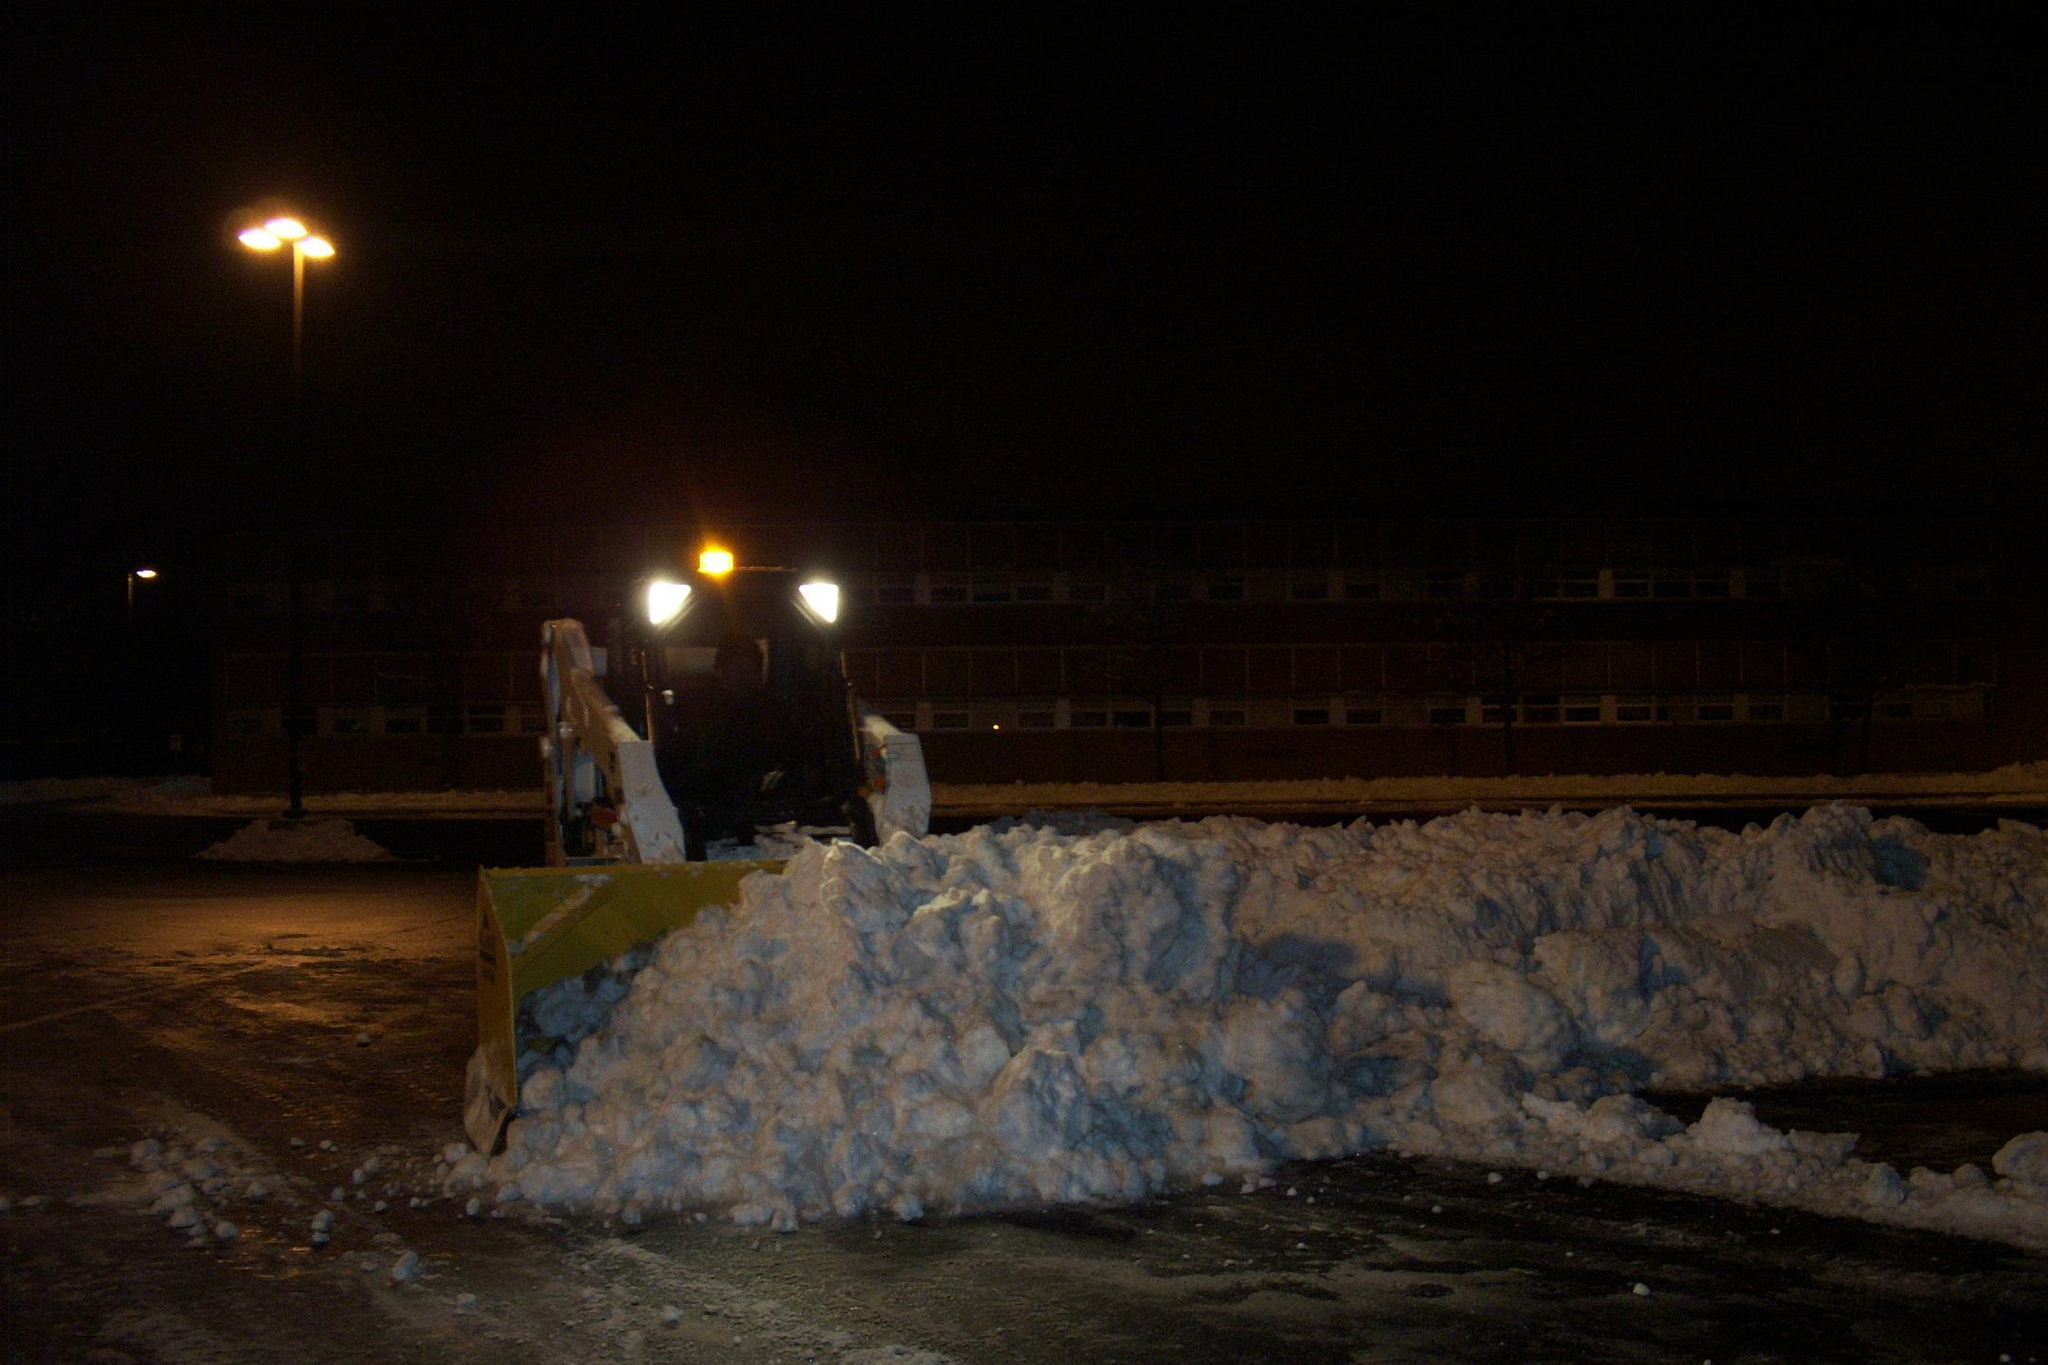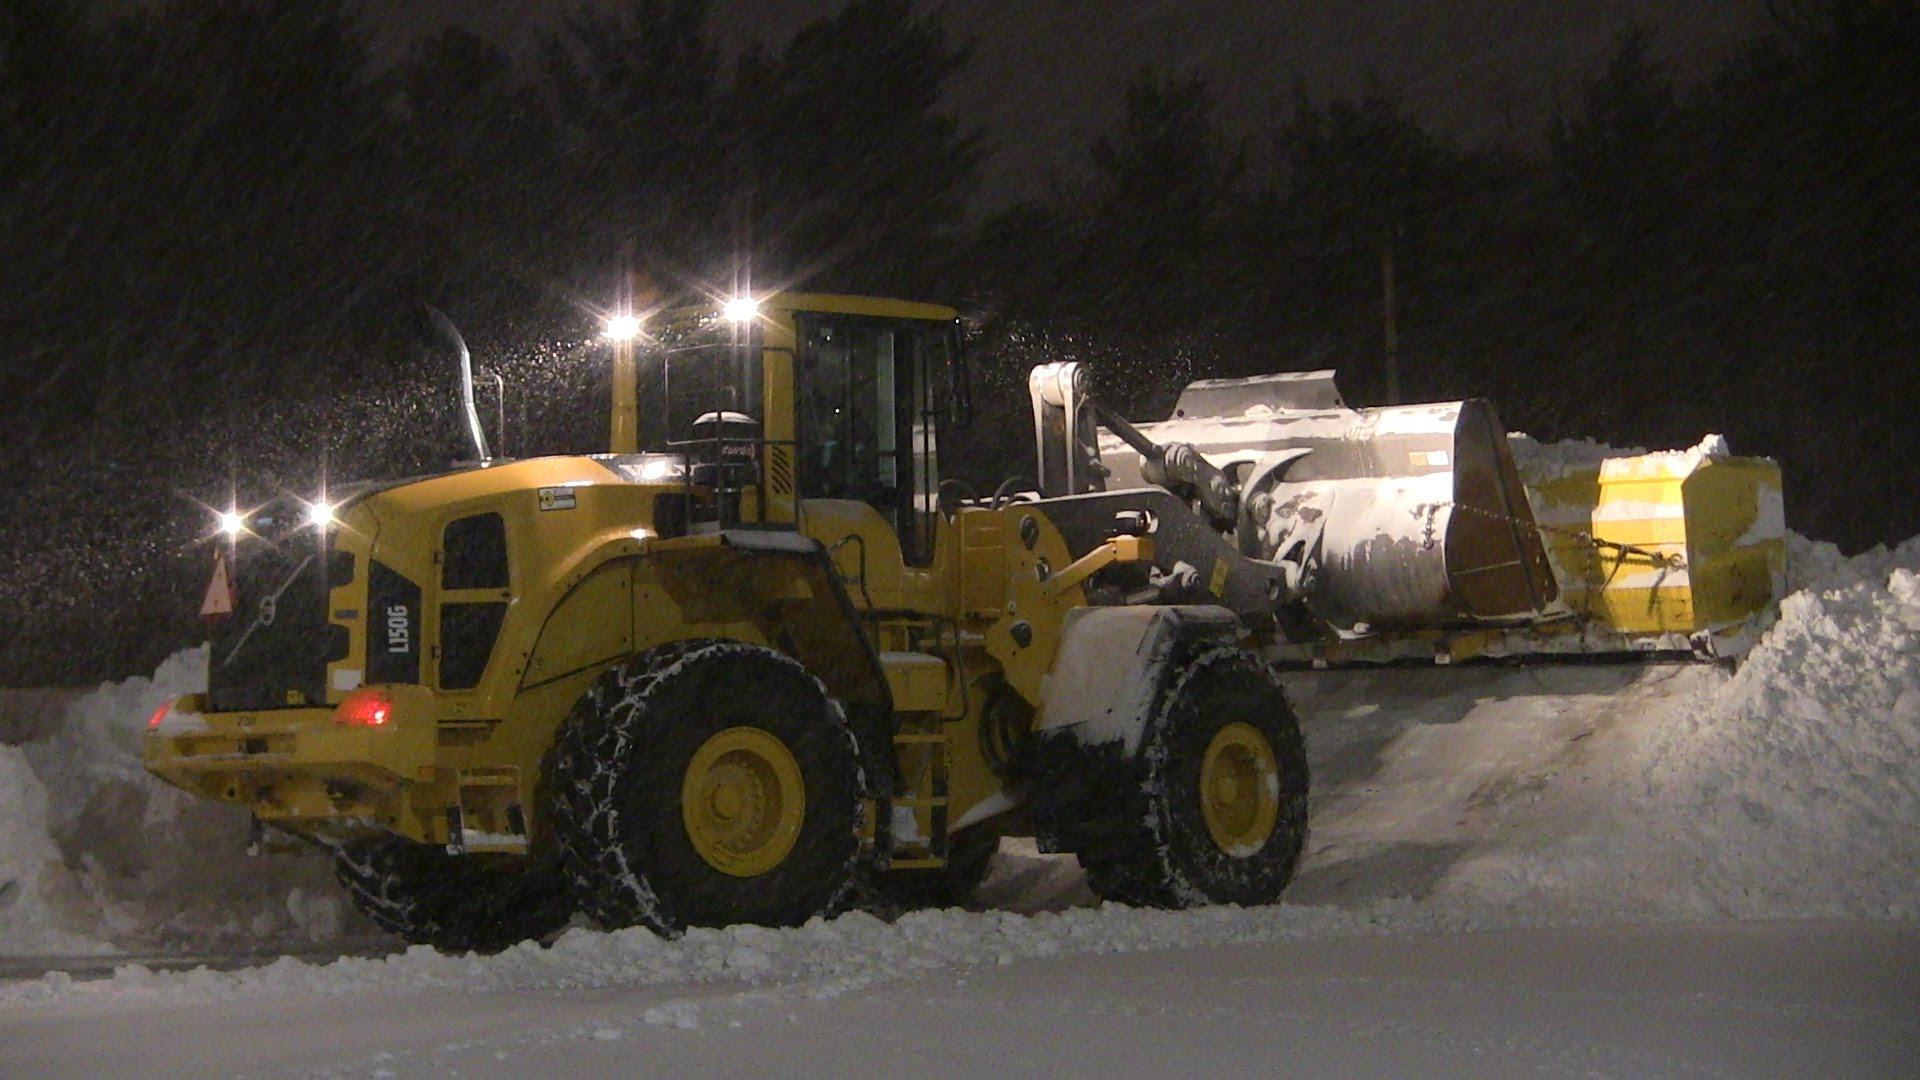The first image is the image on the left, the second image is the image on the right. Considering the images on both sides, is "There is a total of two trackers plowing snow." valid? Answer yes or no. Yes. The first image is the image on the left, the second image is the image on the right. For the images displayed, is the sentence "An image shows a tractor-type plow with two bright white lights at the top pushing snow as the snow falls around it." factually correct? Answer yes or no. Yes. 